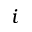<formula> <loc_0><loc_0><loc_500><loc_500>i</formula> 